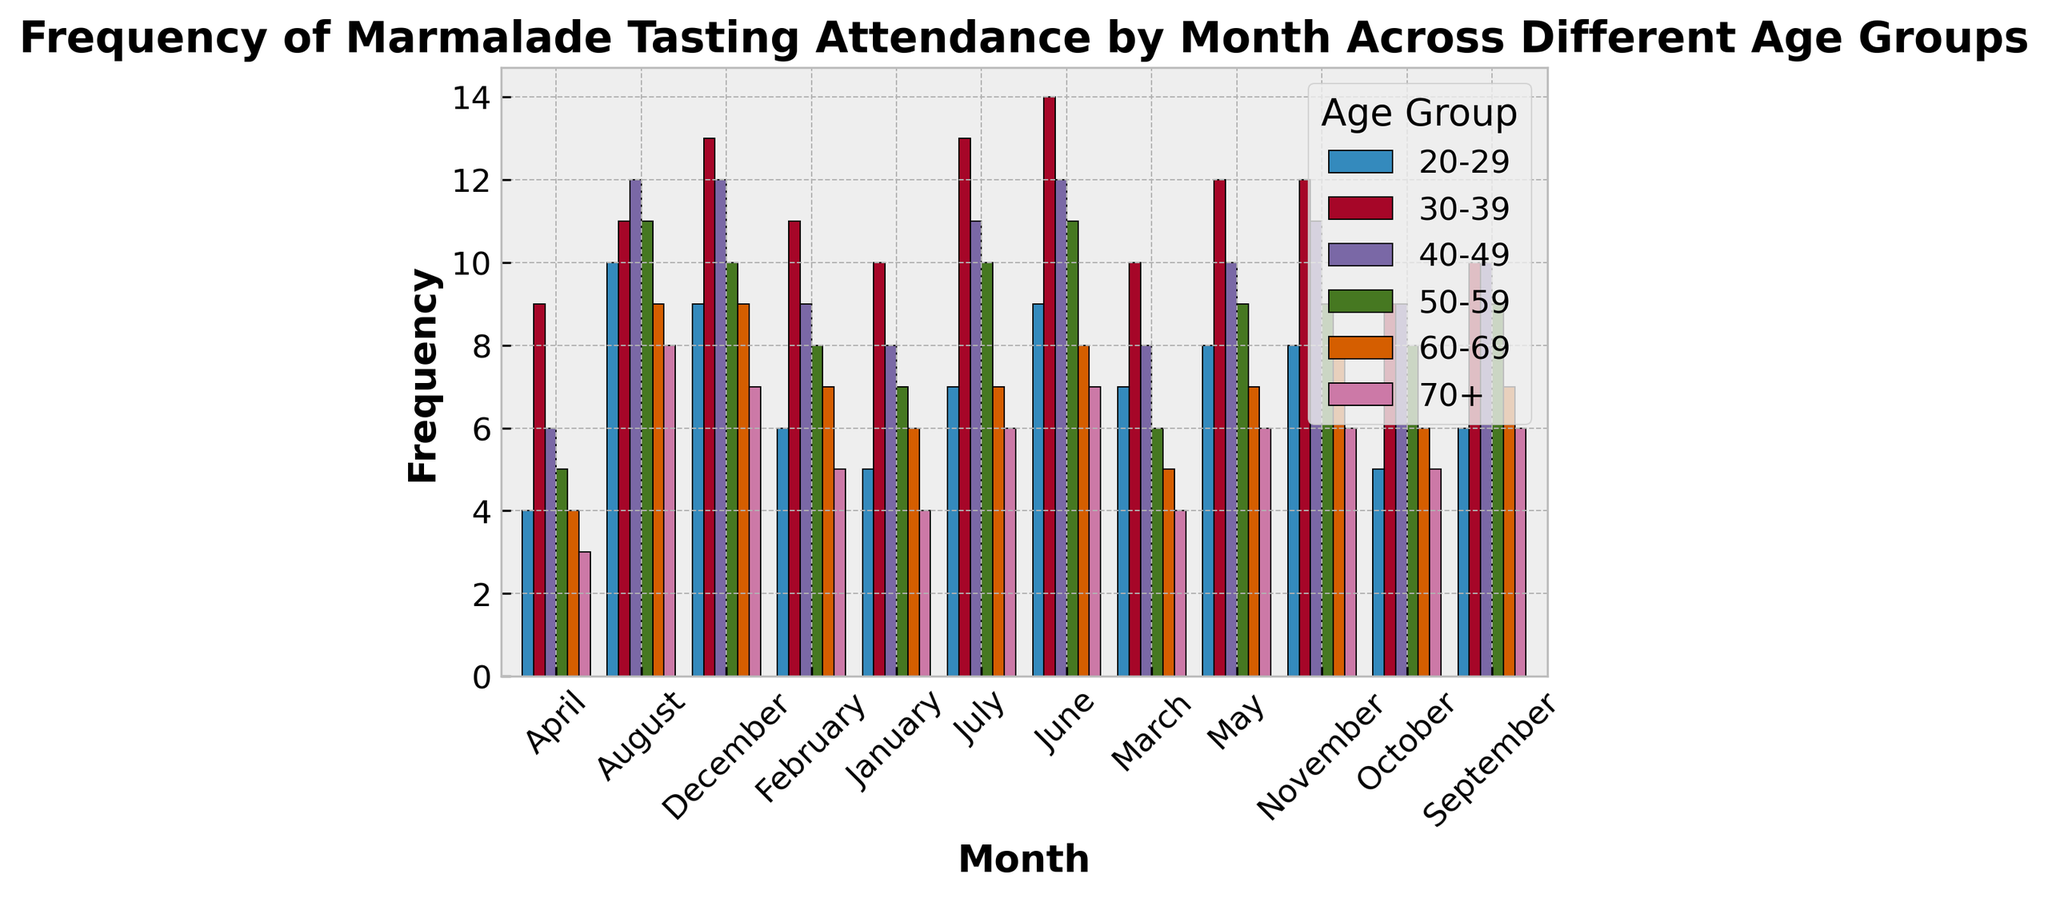Which age group had the highest frequency of attendance in August? First, identify the month of August on the x-axis. Then, look for the tallest bar in the cluster for August and check its corresponding age group in the legend.
Answer: 20-29 Comparing the 30-39 and 40-49 age groups, which month had the closest attendance frequencies? Compare the heights of the bars for each month for the 30-39 and 40-49 age groups. Look for the month where the bars for these two age groups are nearly the same height.
Answer: November What is the average frequency of attendance in June for all age groups? Locate the bars for June, sum their heights (frequencies) for all age groups: 9 (20-29) + 14 (30-39) + 12 (40-49) + 11 (50-59) + 8 (60-69) + 7 (70+). Then, divide by the number of age groups (6).
Answer: 10.17 Which month had the lowest attendance frequency for the 70+ age group? Identify each monthly bar for the 70+ age group (color coded by legend), and find which one is the shortest.
Answer: April Between 20-29 and 50-59 age groups, which had higher attendance in March and by how much? Locate the March bars for both age groups, see the heights, and subtract the frequency of the 50-59 age group from the 20-29 age group: 7 - 6.
Answer: 1 In which months did the 60-69 age group have the same frequency of attendance? Find and compare all bar heights for the 60-69 age group. Identify months where the bars' heights are identical.
Answer: February and September Calculate the total annual attendance frequency for the 30-39 age group. Sum the heights of the bars representing each month for the 30-39 age group: 10 + 11 + 10 + 9 + 12 + 14 + 13 + 11 + 10 + 9 + 12 + 13.
Answer: 134 For the 40-49 age group, which month had the highest frequency of attendance and what is its value? Identify the tallest bar in the 40-49 age group by comparing the heights for every month, then determine its value.
Answer: August, 12 What is the median attendance frequency for the 20-29 age group? List the attendance frequencies for each month in ascending order: 4, 5, 5, 6, 7, 7, 7, 8, 8, 9, 9, 10, and find the middle value(s).
Answer: 7 